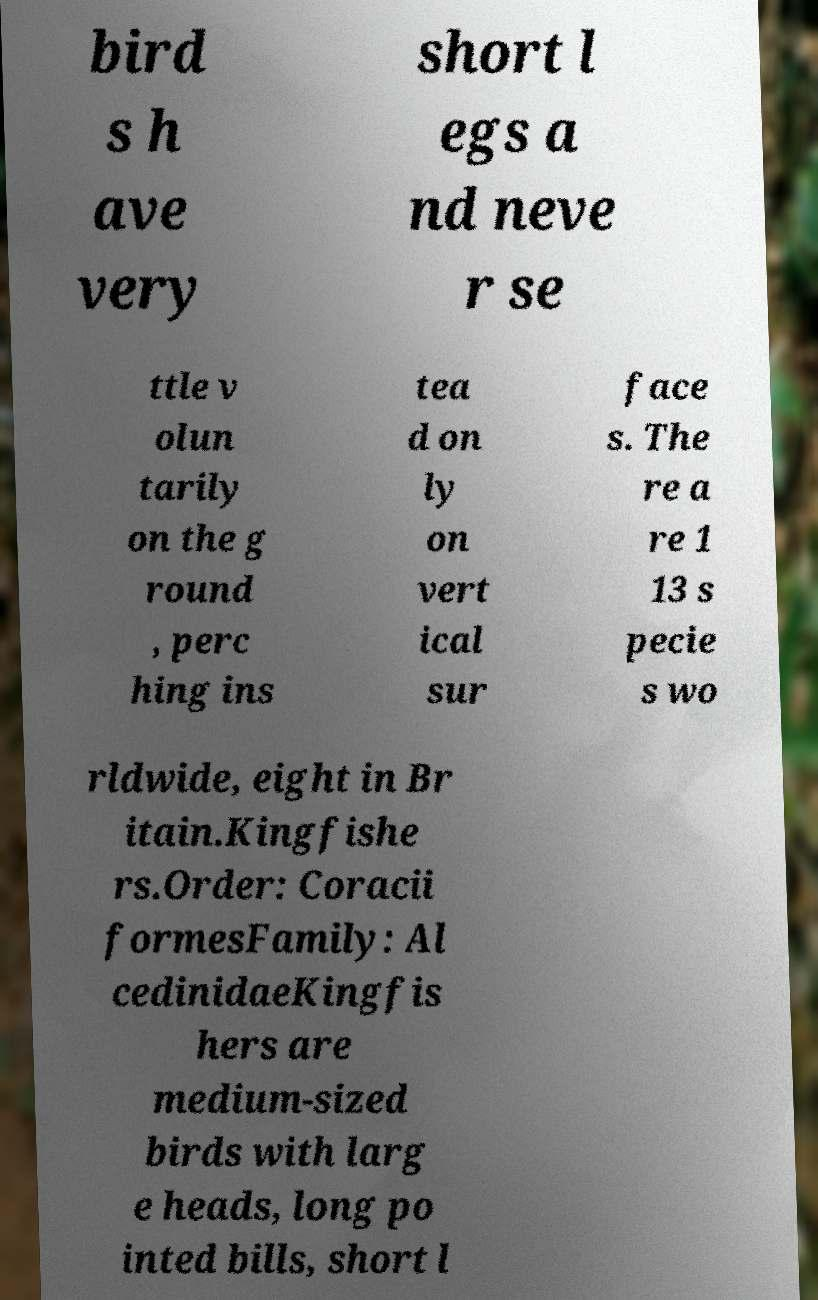Could you assist in decoding the text presented in this image and type it out clearly? bird s h ave very short l egs a nd neve r se ttle v olun tarily on the g round , perc hing ins tea d on ly on vert ical sur face s. The re a re 1 13 s pecie s wo rldwide, eight in Br itain.Kingfishe rs.Order: Coracii formesFamily: Al cedinidaeKingfis hers are medium-sized birds with larg e heads, long po inted bills, short l 